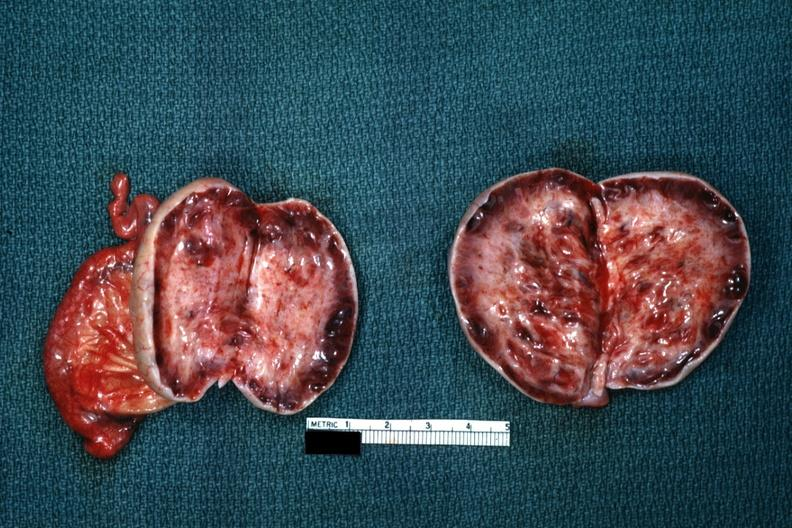s breast present?
Answer the question using a single word or phrase. No 